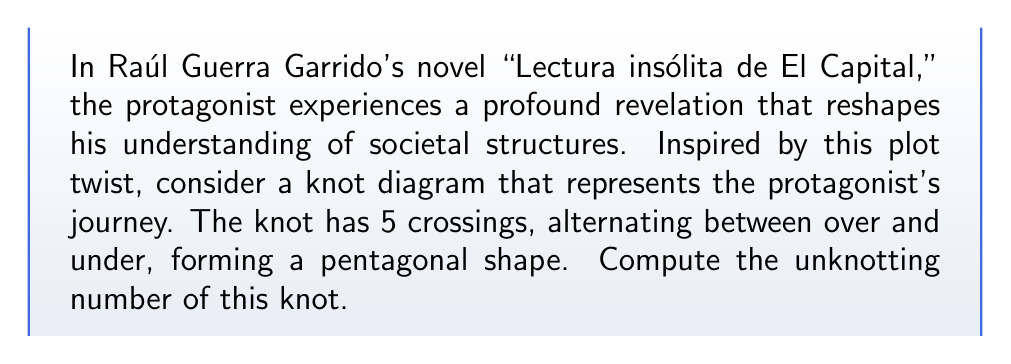Help me with this question. To determine the unknotting number of this knot inspired by Guerra Garrido's work, we'll follow these steps:

1) First, we need to identify the knot. The description suggests a pentagonal shape with 5 alternating crossings, which corresponds to the knot known as the cinquefoil knot or $5_1$ in Alexander-Briggs notation.

2) For the cinquefoil knot, we can use the following properties:
   - It is a torus knot of type (2,5)
   - It is a prime knot
   - It has a crossing number of 5

3) For torus knots of type (p,q) where p and q are coprime, the unknotting number u is given by the formula:

   $$ u = \frac{(p-1)(q-1)}{2} $$

4) In our case, p = 2 and q = 5. Let's substitute these values:

   $$ u = \frac{(2-1)(5-1)}{2} = \frac{1 \cdot 4}{2} = 2 $$

5) Therefore, the unknotting number of the cinquefoil knot is 2.

This means that a minimum of 2 crossing changes are required to transform this knot into the unknot, reflecting the significant transformation in the protagonist's perspective in Guerra Garrido's novel.
Answer: 2 